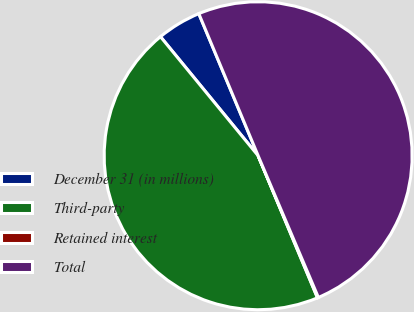Convert chart to OTSL. <chart><loc_0><loc_0><loc_500><loc_500><pie_chart><fcel>December 31 (in millions)<fcel>Third-party<fcel>Retained interest<fcel>Total<nl><fcel>4.64%<fcel>45.36%<fcel>0.1%<fcel>49.9%<nl></chart> 